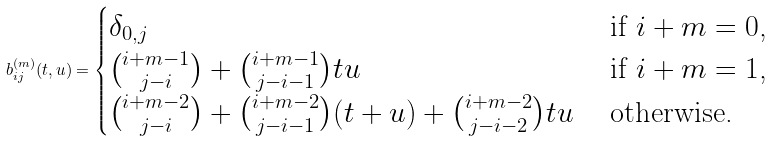Convert formula to latex. <formula><loc_0><loc_0><loc_500><loc_500>b ^ { ( m ) } _ { i j } ( t , u ) = \begin{cases} \delta _ { 0 , j } & \text { if $i+m=0$,} \\ \binom { i + m - 1 } { j - i } + \binom { i + m - 1 } { j - i - 1 } t u & \text { if $i+m=1$,} \\ \binom { i + m - 2 } { j - i } + \binom { i + m - 2 } { j - i - 1 } ( t + u ) + \binom { i + m - 2 } { j - i - 2 } t u & \text { otherwise.} \end{cases}</formula> 